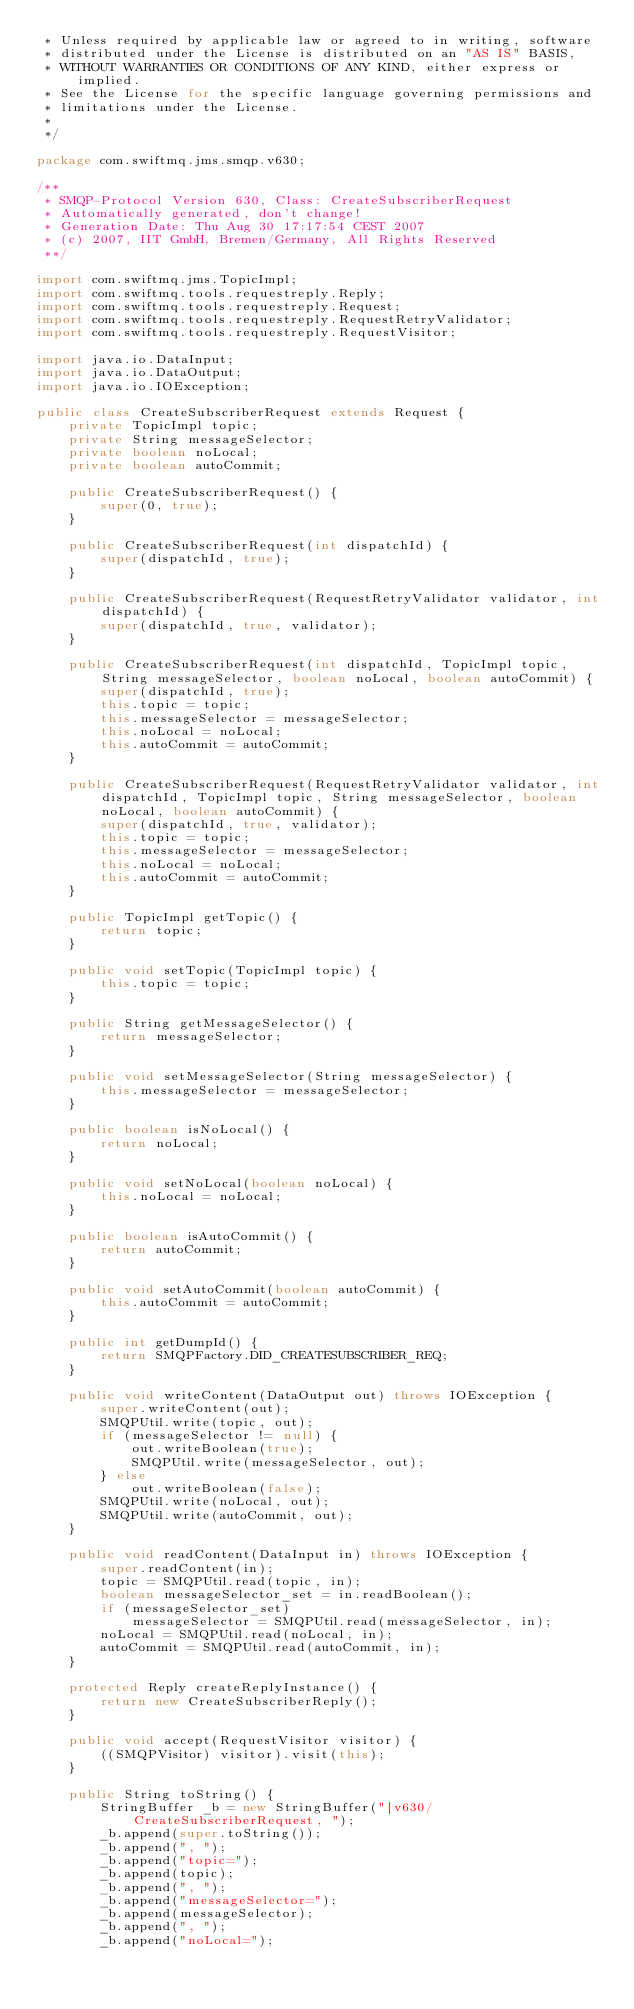<code> <loc_0><loc_0><loc_500><loc_500><_Java_> * Unless required by applicable law or agreed to in writing, software
 * distributed under the License is distributed on an "AS IS" BASIS,
 * WITHOUT WARRANTIES OR CONDITIONS OF ANY KIND, either express or implied.
 * See the License for the specific language governing permissions and
 * limitations under the License.
 *
 */

package com.swiftmq.jms.smqp.v630;

/**
 * SMQP-Protocol Version 630, Class: CreateSubscriberRequest
 * Automatically generated, don't change!
 * Generation Date: Thu Aug 30 17:17:54 CEST 2007
 * (c) 2007, IIT GmbH, Bremen/Germany, All Rights Reserved
 **/

import com.swiftmq.jms.TopicImpl;
import com.swiftmq.tools.requestreply.Reply;
import com.swiftmq.tools.requestreply.Request;
import com.swiftmq.tools.requestreply.RequestRetryValidator;
import com.swiftmq.tools.requestreply.RequestVisitor;

import java.io.DataInput;
import java.io.DataOutput;
import java.io.IOException;

public class CreateSubscriberRequest extends Request {
    private TopicImpl topic;
    private String messageSelector;
    private boolean noLocal;
    private boolean autoCommit;

    public CreateSubscriberRequest() {
        super(0, true);
    }

    public CreateSubscriberRequest(int dispatchId) {
        super(dispatchId, true);
    }

    public CreateSubscriberRequest(RequestRetryValidator validator, int dispatchId) {
        super(dispatchId, true, validator);
    }

    public CreateSubscriberRequest(int dispatchId, TopicImpl topic, String messageSelector, boolean noLocal, boolean autoCommit) {
        super(dispatchId, true);
        this.topic = topic;
        this.messageSelector = messageSelector;
        this.noLocal = noLocal;
        this.autoCommit = autoCommit;
    }

    public CreateSubscriberRequest(RequestRetryValidator validator, int dispatchId, TopicImpl topic, String messageSelector, boolean noLocal, boolean autoCommit) {
        super(dispatchId, true, validator);
        this.topic = topic;
        this.messageSelector = messageSelector;
        this.noLocal = noLocal;
        this.autoCommit = autoCommit;
    }

    public TopicImpl getTopic() {
        return topic;
    }

    public void setTopic(TopicImpl topic) {
        this.topic = topic;
    }

    public String getMessageSelector() {
        return messageSelector;
    }

    public void setMessageSelector(String messageSelector) {
        this.messageSelector = messageSelector;
    }

    public boolean isNoLocal() {
        return noLocal;
    }

    public void setNoLocal(boolean noLocal) {
        this.noLocal = noLocal;
    }

    public boolean isAutoCommit() {
        return autoCommit;
    }

    public void setAutoCommit(boolean autoCommit) {
        this.autoCommit = autoCommit;
    }

    public int getDumpId() {
        return SMQPFactory.DID_CREATESUBSCRIBER_REQ;
    }

    public void writeContent(DataOutput out) throws IOException {
        super.writeContent(out);
        SMQPUtil.write(topic, out);
        if (messageSelector != null) {
            out.writeBoolean(true);
            SMQPUtil.write(messageSelector, out);
        } else
            out.writeBoolean(false);
        SMQPUtil.write(noLocal, out);
        SMQPUtil.write(autoCommit, out);
    }

    public void readContent(DataInput in) throws IOException {
        super.readContent(in);
        topic = SMQPUtil.read(topic, in);
        boolean messageSelector_set = in.readBoolean();
        if (messageSelector_set)
            messageSelector = SMQPUtil.read(messageSelector, in);
        noLocal = SMQPUtil.read(noLocal, in);
        autoCommit = SMQPUtil.read(autoCommit, in);
    }

    protected Reply createReplyInstance() {
        return new CreateSubscriberReply();
    }

    public void accept(RequestVisitor visitor) {
        ((SMQPVisitor) visitor).visit(this);
    }

    public String toString() {
        StringBuffer _b = new StringBuffer("[v630/CreateSubscriberRequest, ");
        _b.append(super.toString());
        _b.append(", ");
        _b.append("topic=");
        _b.append(topic);
        _b.append(", ");
        _b.append("messageSelector=");
        _b.append(messageSelector);
        _b.append(", ");
        _b.append("noLocal=");</code> 